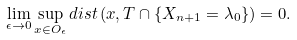Convert formula to latex. <formula><loc_0><loc_0><loc_500><loc_500>\lim _ { \epsilon \to 0 } \sup _ { x \in O _ { \epsilon } } d i s t \left ( x , T \cap \{ X _ { n + 1 } = \lambda _ { 0 } \} \right ) = 0 .</formula> 